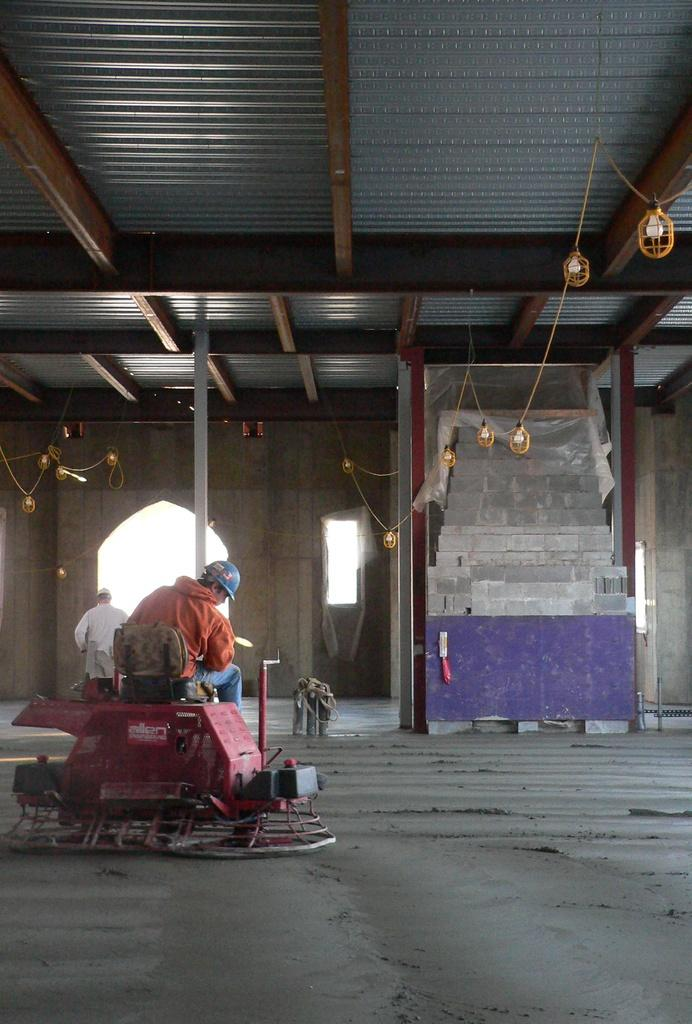What is the sitting person doing in the image? The sitting person is on a machine in the image. Where is the sitting person located in the image? The sitting person is on the left side of the image. Can you describe the position of the standing person in relation to the sitting person? There is another person standing at the back of the sitting person. What type of drum can be seen on the nose of the sitting person in the image? There is no drum or any musical instrument visible on the nose of the sitting person in the image. How many muscles are flexed by the standing person in the image? There is no information about the standing person's muscles in the image, so it cannot be determined. 